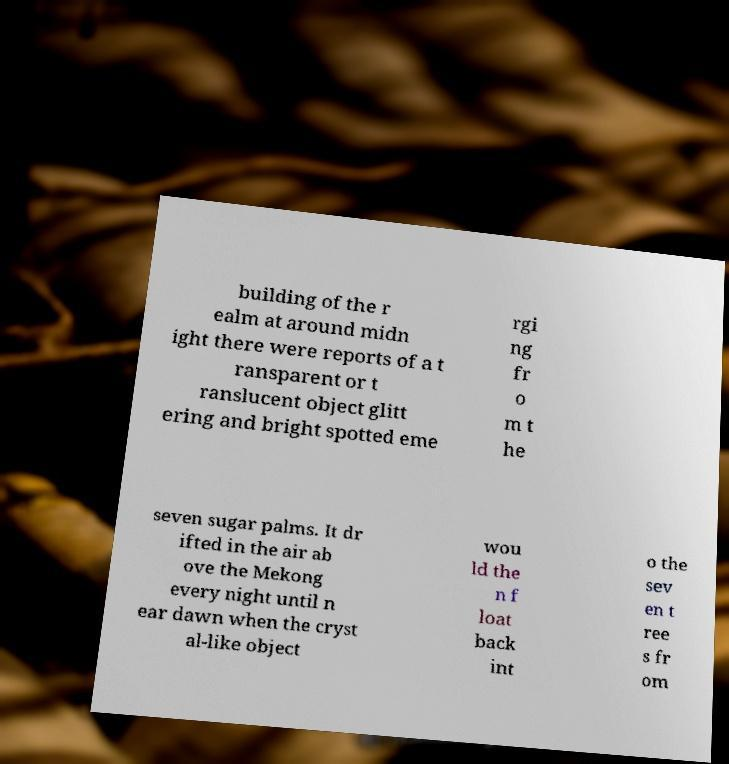Can you accurately transcribe the text from the provided image for me? building of the r ealm at around midn ight there were reports of a t ransparent or t ranslucent object glitt ering and bright spotted eme rgi ng fr o m t he seven sugar palms. It dr ifted in the air ab ove the Mekong every night until n ear dawn when the cryst al-like object wou ld the n f loat back int o the sev en t ree s fr om 